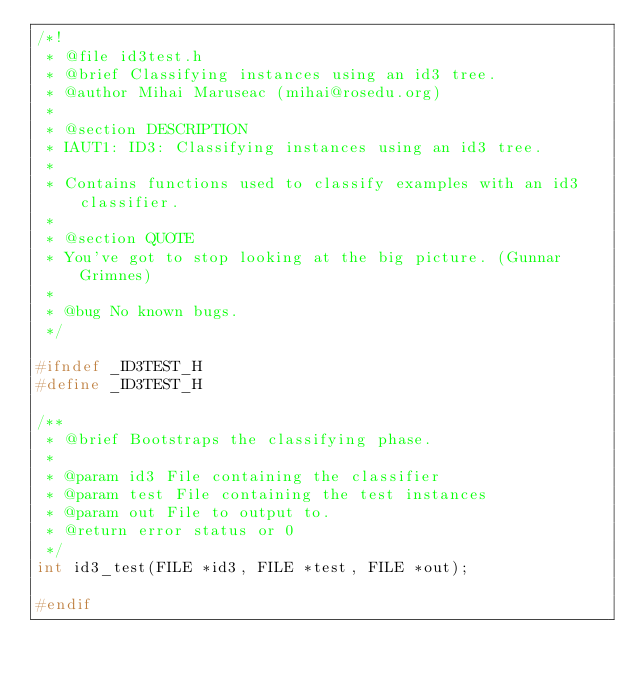Convert code to text. <code><loc_0><loc_0><loc_500><loc_500><_C_>/*!
 * @file id3test.h
 * @brief Classifying instances using an id3 tree.
 * @author Mihai Maruseac (mihai@rosedu.org)
 *
 * @section DESCRIPTION
 * IAUT1: ID3: Classifying instances using an id3 tree.
 *
 * Contains functions used to classify examples with an id3 classifier.
 *
 * @section QUOTE
 * You've got to stop looking at the big picture. (Gunnar Grimnes)
 *
 * @bug No known bugs.
 */

#ifndef _ID3TEST_H
#define _ID3TEST_H

/**
 * @brief Bootstraps the classifying phase.
 *
 * @param id3 File containing the classifier
 * @param test File containing the test instances
 * @param out File to output to.
 * @return error status or 0
 */
int id3_test(FILE *id3, FILE *test, FILE *out);

#endif

</code> 